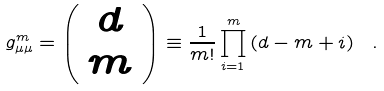Convert formula to latex. <formula><loc_0><loc_0><loc_500><loc_500>g _ { \mu \mu } ^ { m } = \left ( \begin{array} { c } d \\ m \end{array} \right ) \equiv \frac { 1 } { m ! } \prod _ { i = 1 } ^ { m } \left ( d - m + i \right ) \ .</formula> 